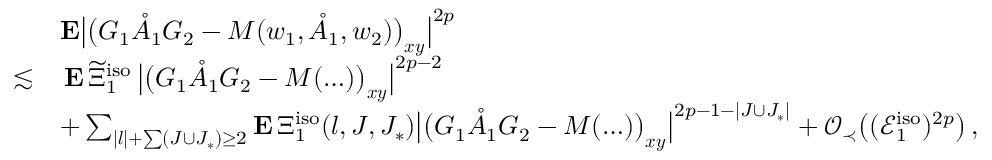Convert formula to latex. <formula><loc_0><loc_0><loc_500><loc_500>\begin{array} { r l } & { E \left | \left ( G _ { 1 } \mathring { A } _ { 1 } G _ { 2 } - M ( w _ { 1 } , \mathring { A } _ { 1 } , w _ { 2 } ) \right ) _ { x y } \right | ^ { 2 p } } \\ { \lesssim } & { \, E \, \widetilde { \Xi } _ { 1 } ^ { i s o } \, \left | \left ( G _ { 1 } \mathring { A } _ { 1 } G _ { 2 } - M ( \dots ) \right ) _ { x y } \right | ^ { 2 p - 2 } } \\ & { + \sum _ { | l | + \sum ( J \cup J _ { * } ) \geq 2 } E \, \Xi _ { 1 } ^ { i s o } ( l , J , J _ { * } ) \left | \left ( G _ { 1 } \mathring { A } _ { 1 } G _ { 2 } - M ( \dots ) \right ) _ { x y } \right | ^ { 2 p - 1 - | J \cup J _ { * } | } + \mathcal { O } _ { \prec } \left ( ( \mathcal { E } _ { 1 } ^ { i s o } ) ^ { 2 p } \right ) \, , } \end{array}</formula> 